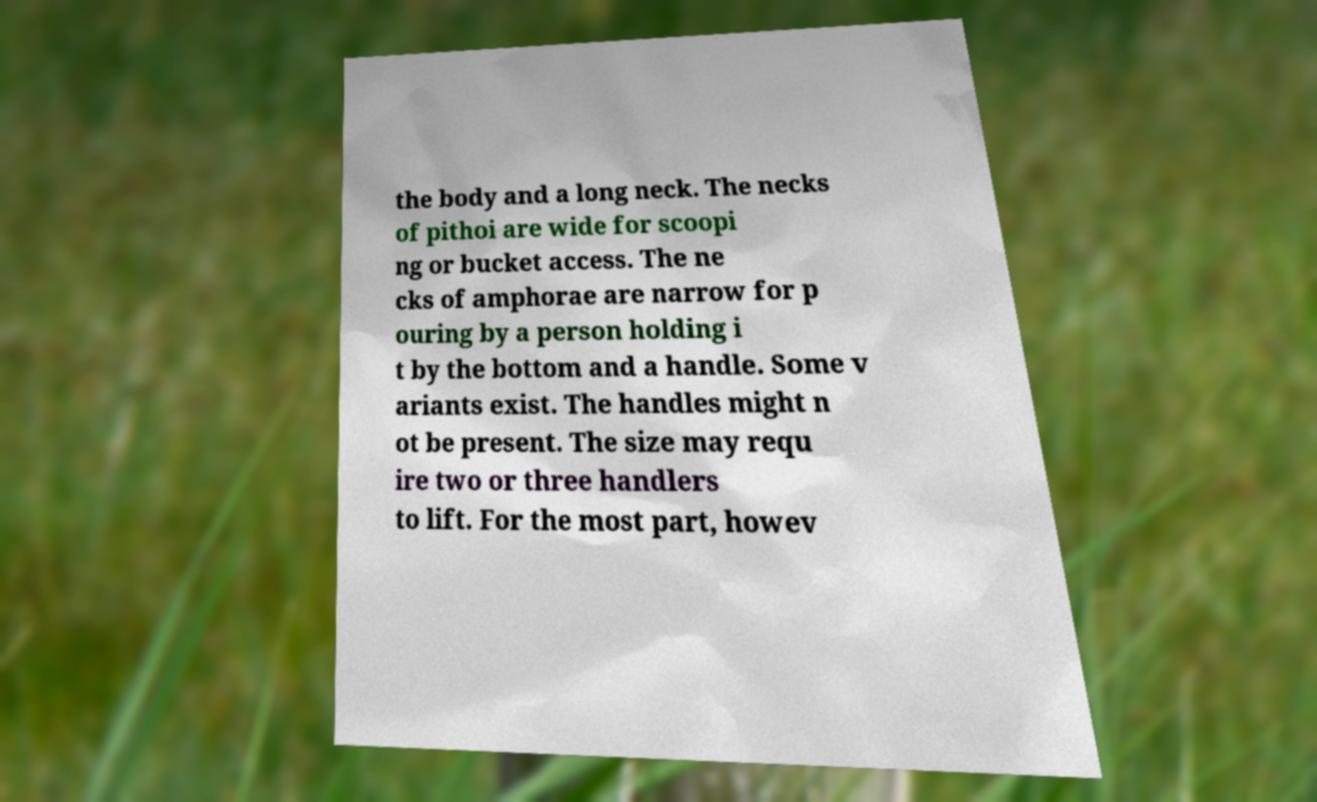There's text embedded in this image that I need extracted. Can you transcribe it verbatim? the body and a long neck. The necks of pithoi are wide for scoopi ng or bucket access. The ne cks of amphorae are narrow for p ouring by a person holding i t by the bottom and a handle. Some v ariants exist. The handles might n ot be present. The size may requ ire two or three handlers to lift. For the most part, howev 